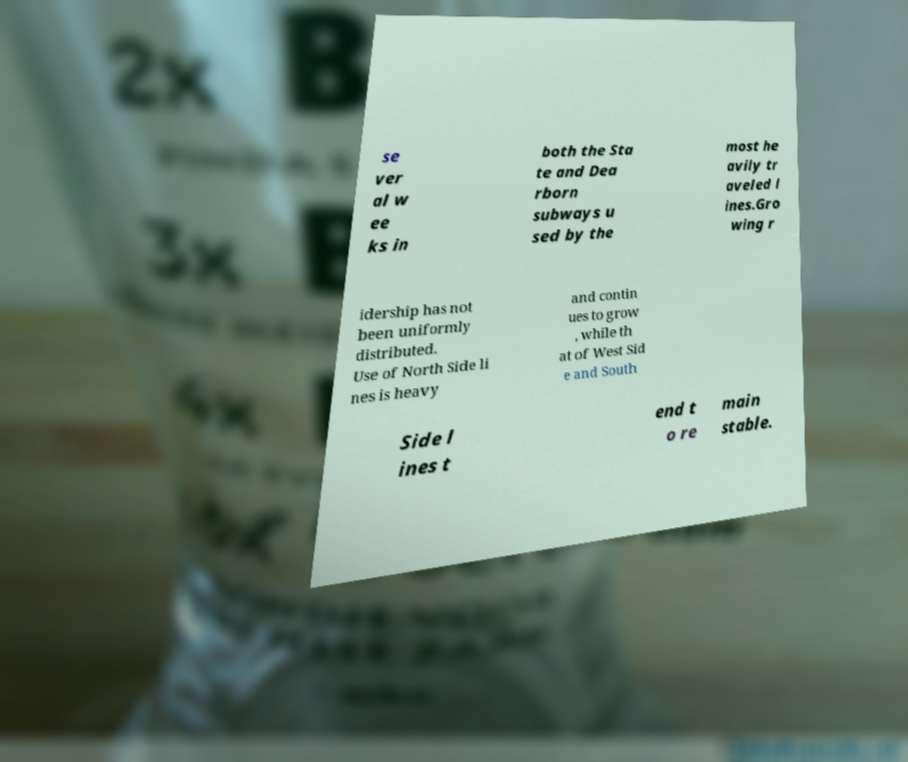Can you accurately transcribe the text from the provided image for me? se ver al w ee ks in both the Sta te and Dea rborn subways u sed by the most he avily tr aveled l ines.Gro wing r idership has not been uniformly distributed. Use of North Side li nes is heavy and contin ues to grow , while th at of West Sid e and South Side l ines t end t o re main stable. 